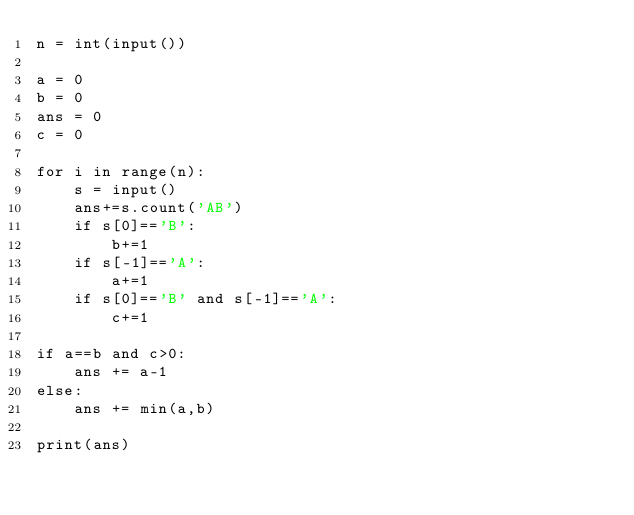<code> <loc_0><loc_0><loc_500><loc_500><_Python_>n = int(input())

a = 0
b = 0
ans = 0
c = 0

for i in range(n):
    s = input()
    ans+=s.count('AB')
    if s[0]=='B':
        b+=1
    if s[-1]=='A':
        a+=1
    if s[0]=='B' and s[-1]=='A':
        c+=1

if a==b and c>0:
    ans += a-1
else:
    ans += min(a,b)

print(ans)</code> 